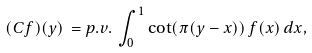<formula> <loc_0><loc_0><loc_500><loc_500>( C f ) ( y ) \, = p . v . \, \int _ { 0 } ^ { 1 } \cot ( \pi ( y - x ) ) \, f ( x ) \, d x ,</formula> 